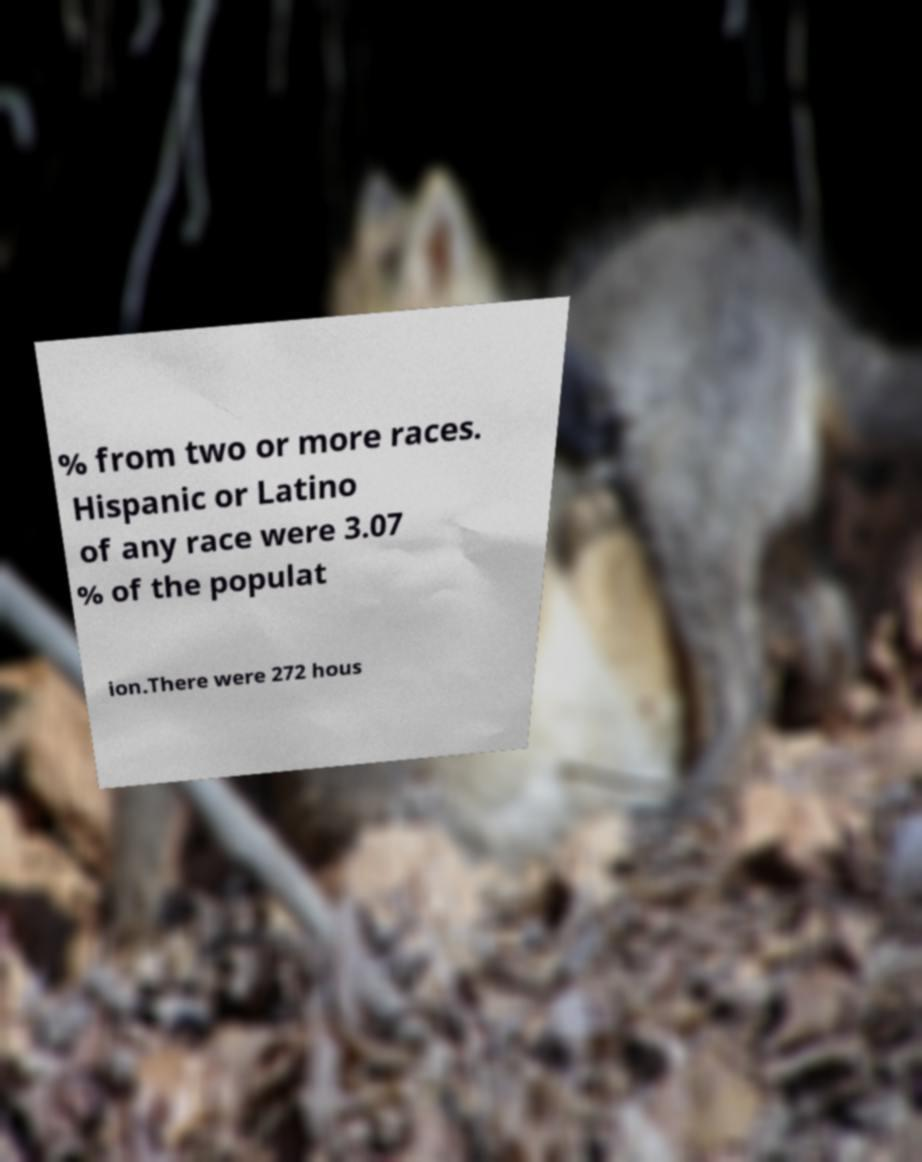I need the written content from this picture converted into text. Can you do that? % from two or more races. Hispanic or Latino of any race were 3.07 % of the populat ion.There were 272 hous 